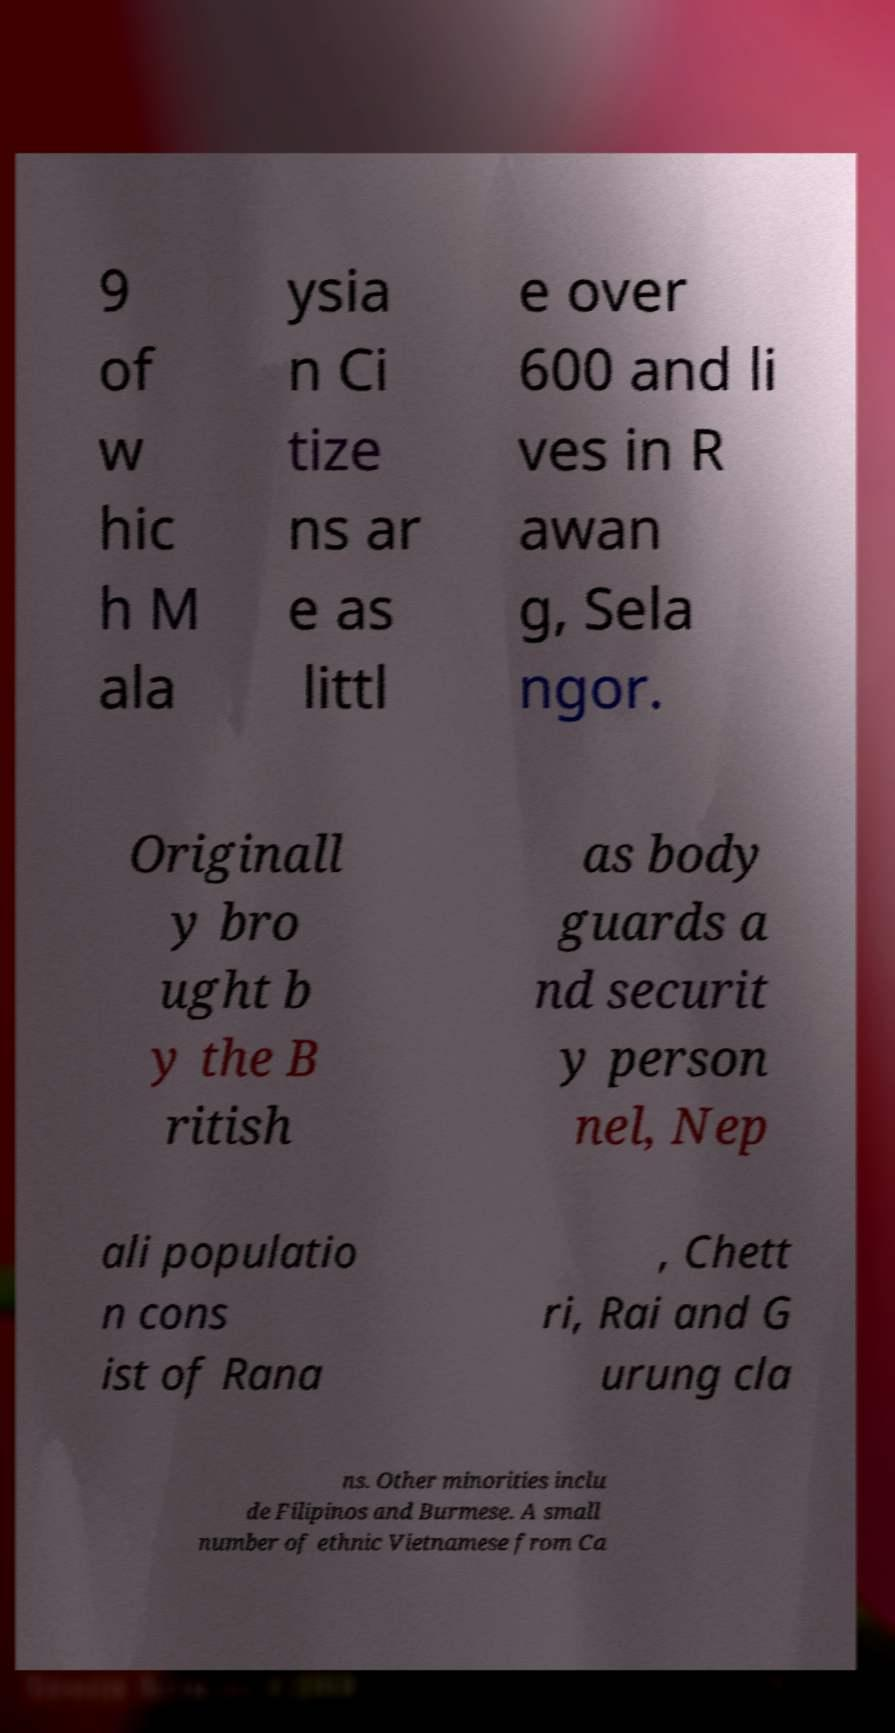What messages or text are displayed in this image? I need them in a readable, typed format. 9 of w hic h M ala ysia n Ci tize ns ar e as littl e over 600 and li ves in R awan g, Sela ngor. Originall y bro ught b y the B ritish as body guards a nd securit y person nel, Nep ali populatio n cons ist of Rana , Chett ri, Rai and G urung cla ns. Other minorities inclu de Filipinos and Burmese. A small number of ethnic Vietnamese from Ca 